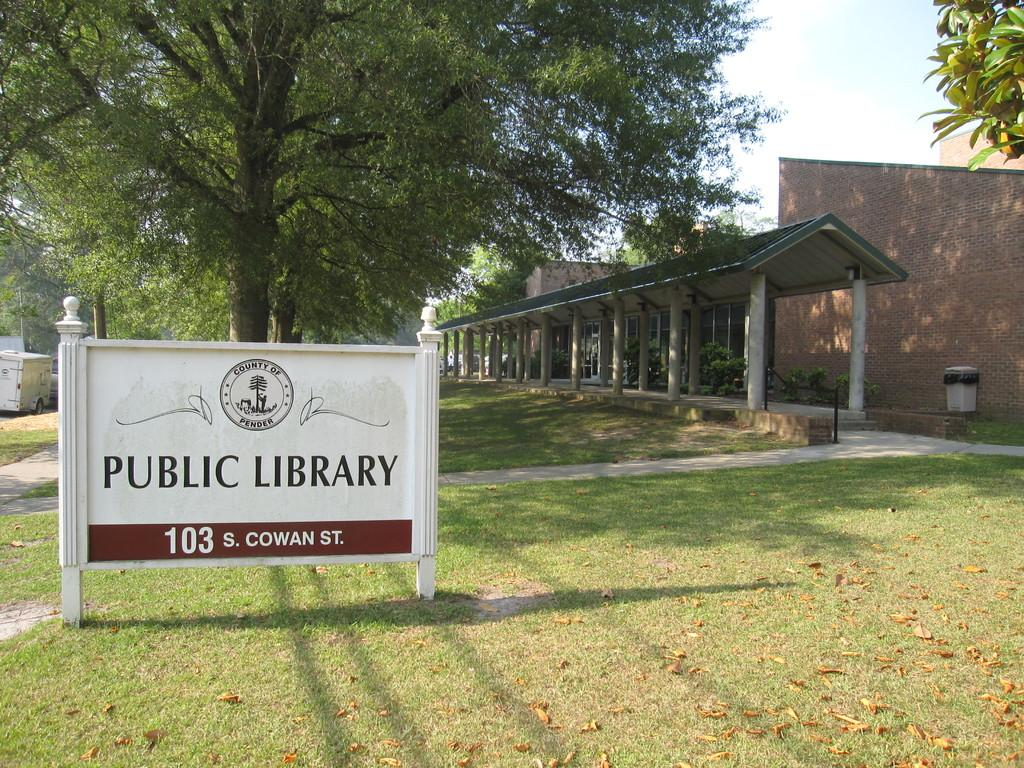What is the main object in the image with poles? There is a name board with poles in the image. What type of vegetation can be seen in the image? There is grass, trees, and plants in the image. What architectural features are present in the image? There are pillars, walls, and a house in the image. What additional objects can be seen in the image? There is a vehicle, a dustbin, and a name board with poles in the image. What is visible in the background of the image? The sky is visible in the background of the image. Can you tell me how many operations the nose has performed in the image? There is no nose or operation present in the image. Is there any blood visible in the image? There is no blood visible in the image. 